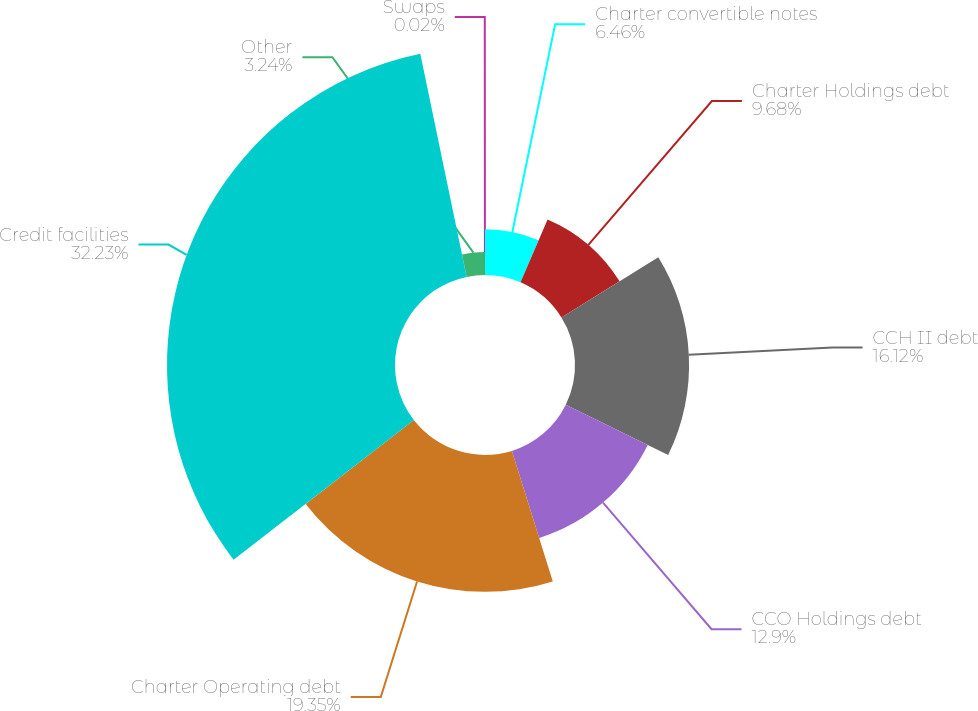Convert chart to OTSL. <chart><loc_0><loc_0><loc_500><loc_500><pie_chart><fcel>Charter convertible notes<fcel>Charter Holdings debt<fcel>CCH II debt<fcel>CCO Holdings debt<fcel>Charter Operating debt<fcel>Credit facilities<fcel>Other<fcel>Swaps<nl><fcel>6.46%<fcel>9.68%<fcel>16.12%<fcel>12.9%<fcel>19.34%<fcel>32.22%<fcel>3.24%<fcel>0.02%<nl></chart> 